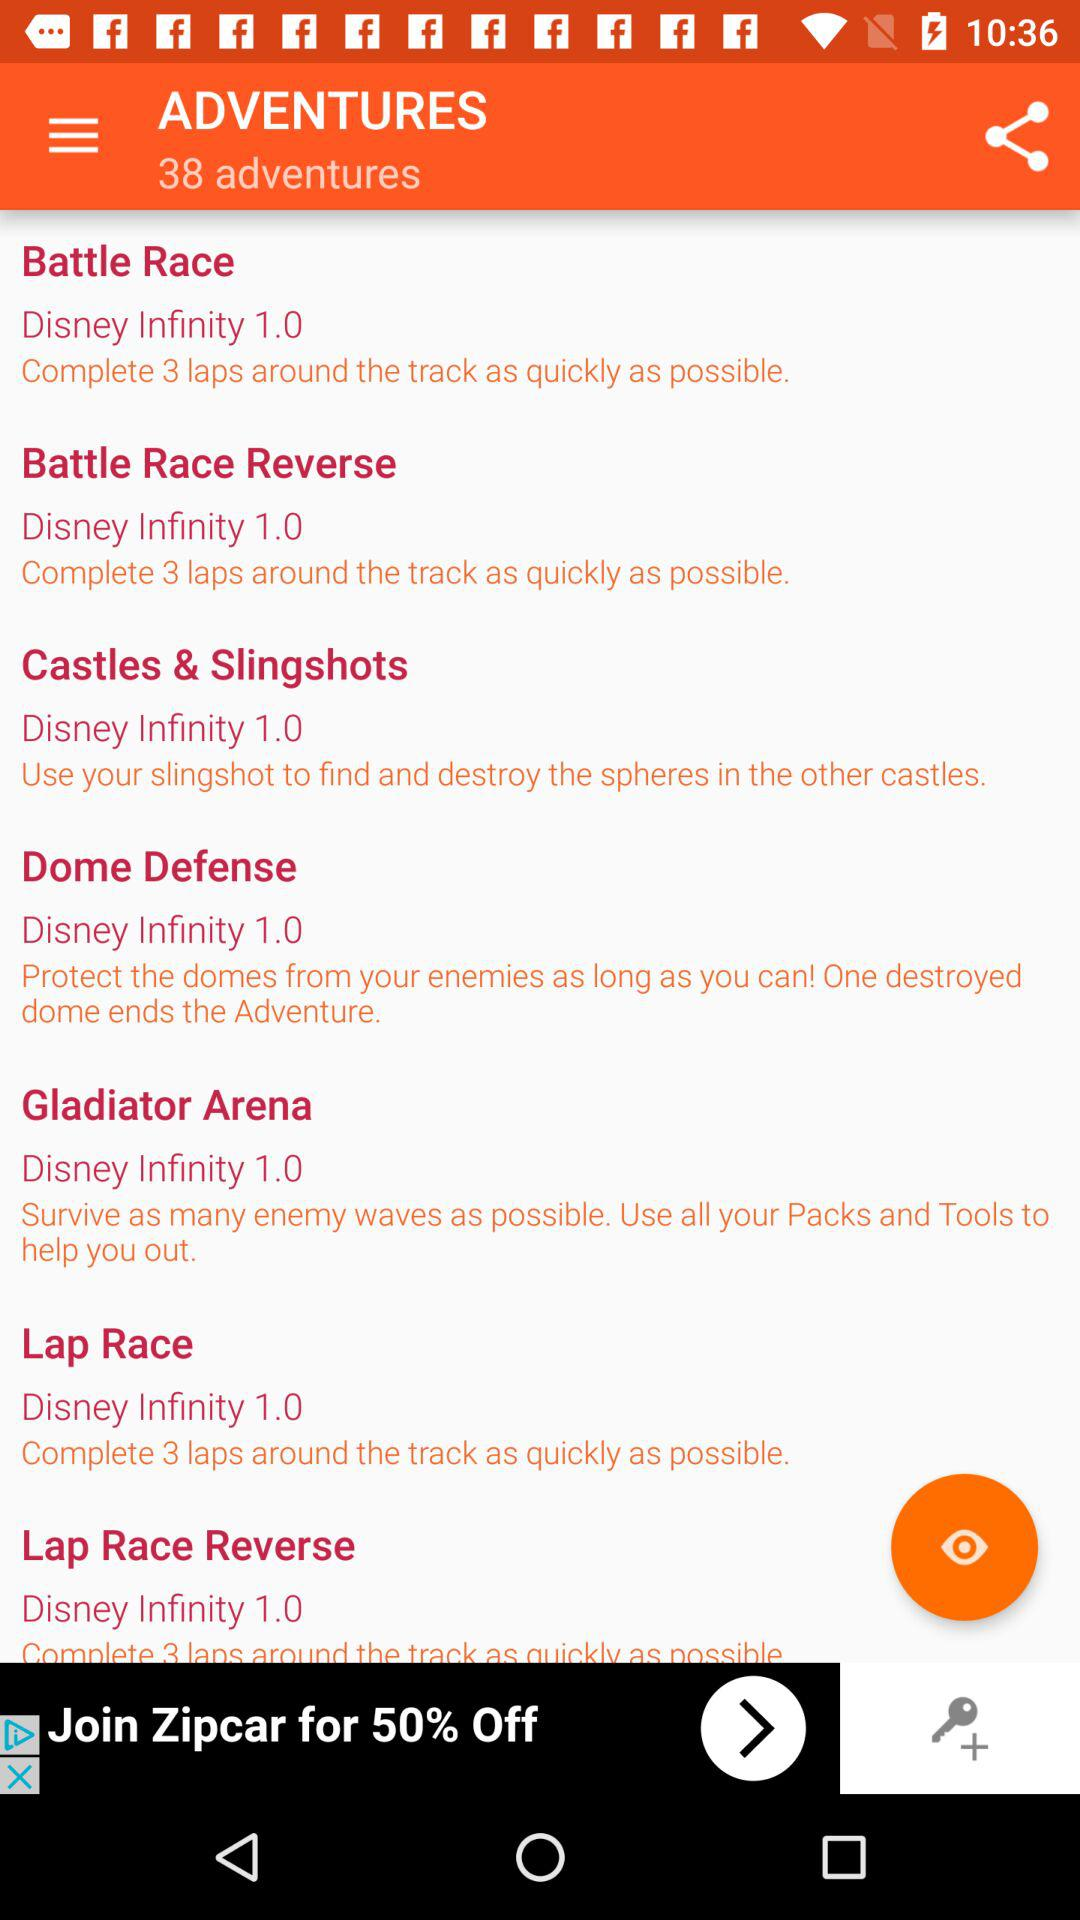What is the version of the battle race?
When the provided information is insufficient, respond with <no answer>. <no answer> 